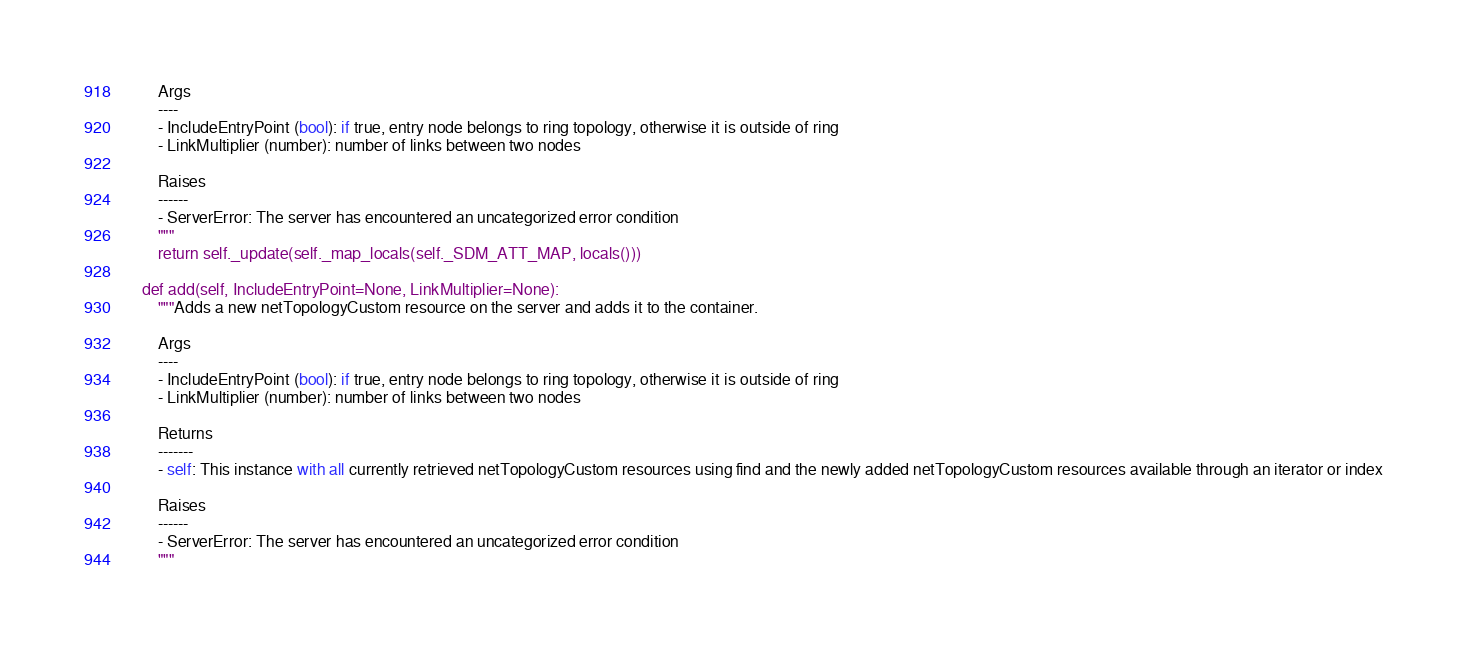<code> <loc_0><loc_0><loc_500><loc_500><_Python_>
        Args
        ----
        - IncludeEntryPoint (bool): if true, entry node belongs to ring topology, otherwise it is outside of ring
        - LinkMultiplier (number): number of links between two nodes

        Raises
        ------
        - ServerError: The server has encountered an uncategorized error condition
        """
        return self._update(self._map_locals(self._SDM_ATT_MAP, locals()))

    def add(self, IncludeEntryPoint=None, LinkMultiplier=None):
        """Adds a new netTopologyCustom resource on the server and adds it to the container.

        Args
        ----
        - IncludeEntryPoint (bool): if true, entry node belongs to ring topology, otherwise it is outside of ring
        - LinkMultiplier (number): number of links between two nodes

        Returns
        -------
        - self: This instance with all currently retrieved netTopologyCustom resources using find and the newly added netTopologyCustom resources available through an iterator or index

        Raises
        ------
        - ServerError: The server has encountered an uncategorized error condition
        """</code> 